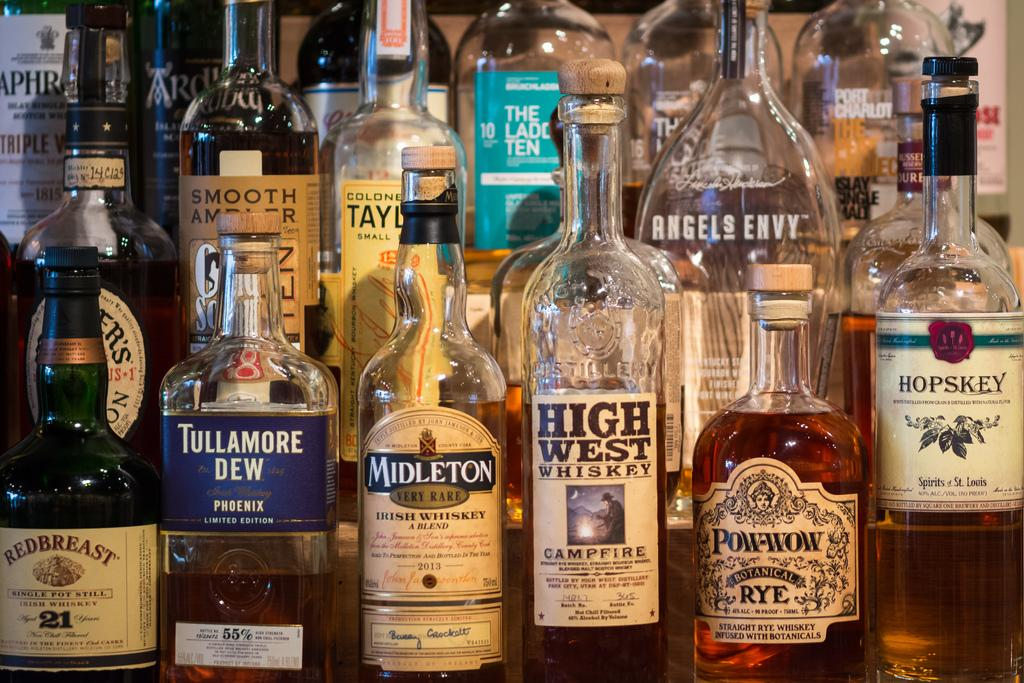<image>
Share a concise interpretation of the image provided. A series of liquor bottles including High West Whiskey and Tullamore Dew. 